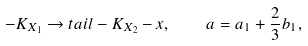Convert formula to latex. <formula><loc_0><loc_0><loc_500><loc_500>- K _ { X _ { 1 } } \rightarrow t a i l - K _ { X _ { 2 } } - x , \quad a = a _ { 1 } + \frac { 2 } { 3 } b _ { 1 } ,</formula> 